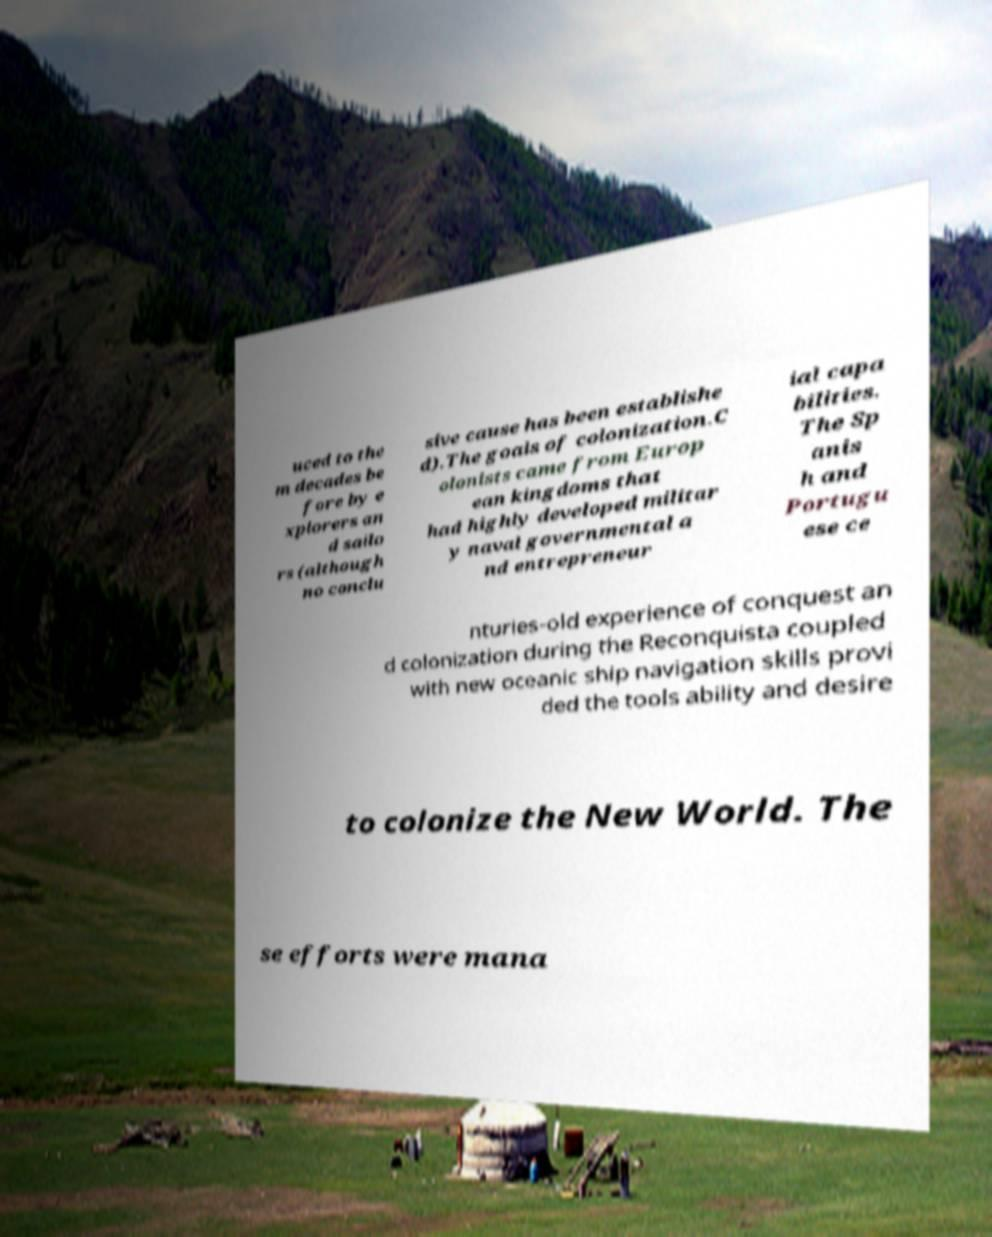Please read and relay the text visible in this image. What does it say? uced to the m decades be fore by e xplorers an d sailo rs (although no conclu sive cause has been establishe d).The goals of colonization.C olonists came from Europ ean kingdoms that had highly developed militar y naval governmental a nd entrepreneur ial capa bilities. The Sp anis h and Portugu ese ce nturies-old experience of conquest an d colonization during the Reconquista coupled with new oceanic ship navigation skills provi ded the tools ability and desire to colonize the New World. The se efforts were mana 